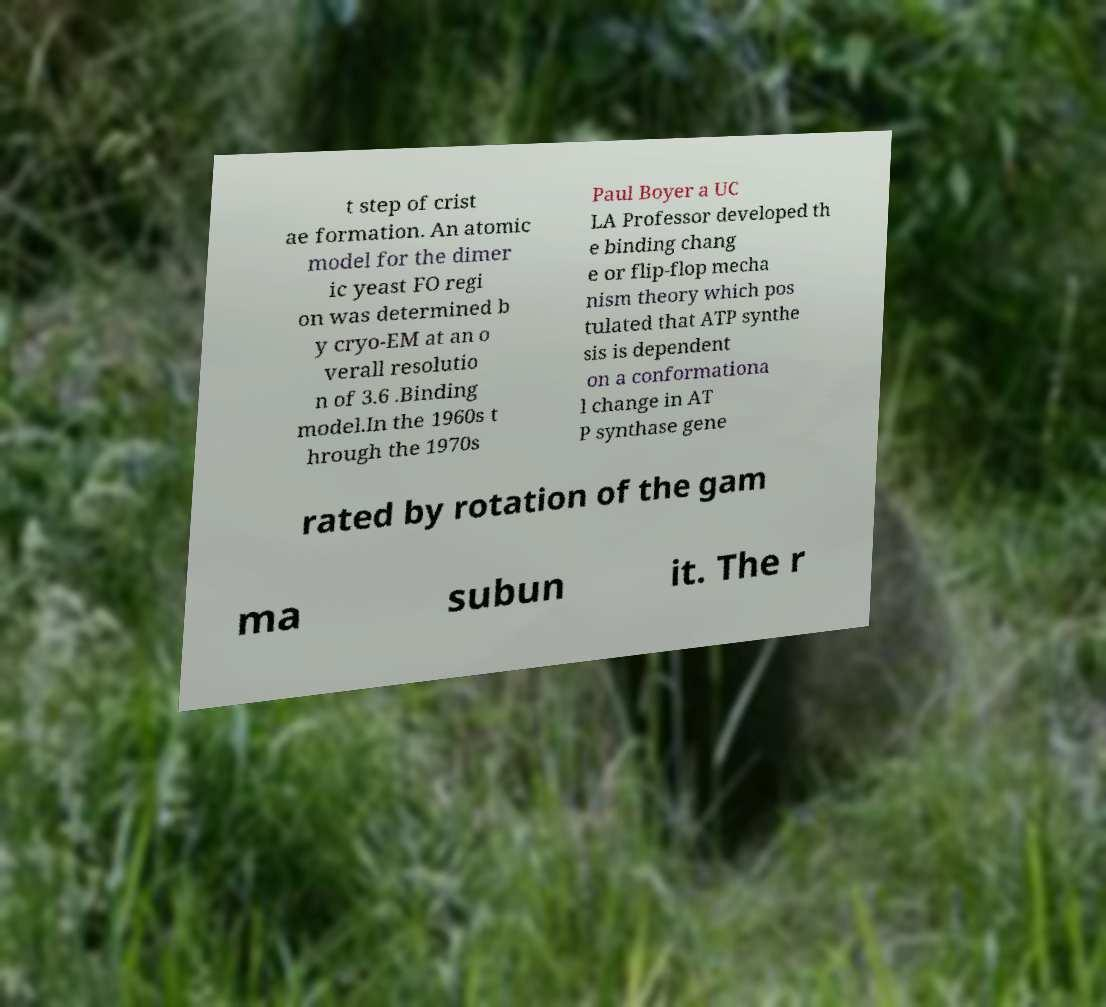I need the written content from this picture converted into text. Can you do that? t step of crist ae formation. An atomic model for the dimer ic yeast FO regi on was determined b y cryo-EM at an o verall resolutio n of 3.6 .Binding model.In the 1960s t hrough the 1970s Paul Boyer a UC LA Professor developed th e binding chang e or flip-flop mecha nism theory which pos tulated that ATP synthe sis is dependent on a conformationa l change in AT P synthase gene rated by rotation of the gam ma subun it. The r 